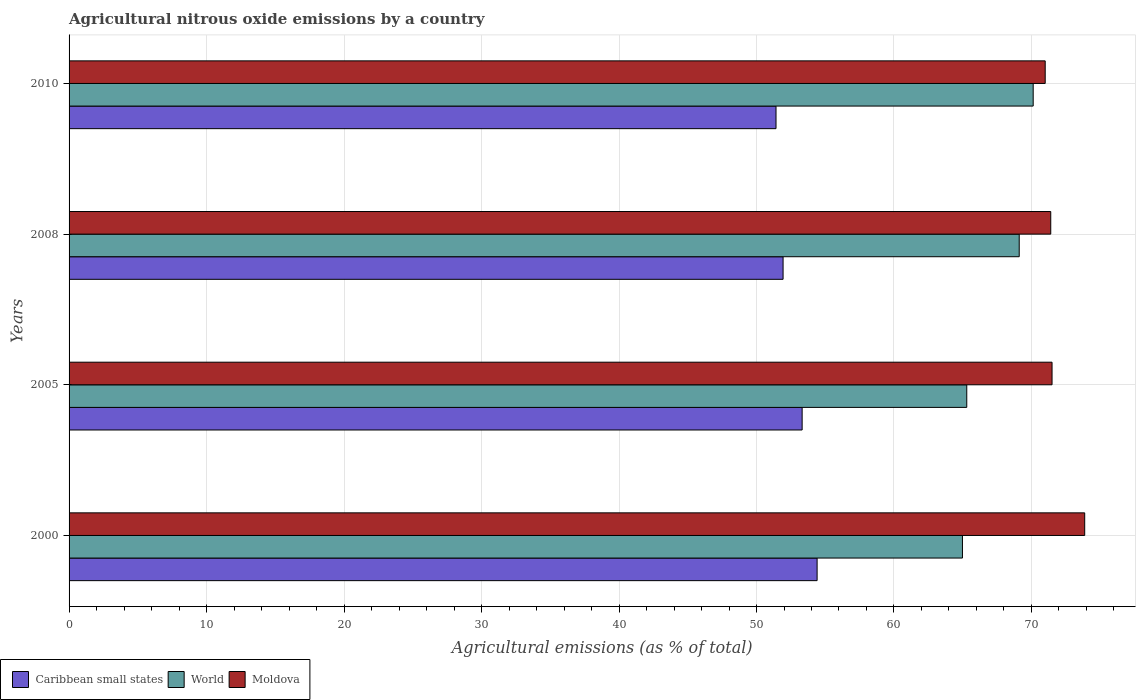How many groups of bars are there?
Your response must be concise. 4. Are the number of bars per tick equal to the number of legend labels?
Ensure brevity in your answer.  Yes. In how many cases, is the number of bars for a given year not equal to the number of legend labels?
Your answer should be very brief. 0. What is the amount of agricultural nitrous oxide emitted in World in 2000?
Make the answer very short. 64.98. Across all years, what is the maximum amount of agricultural nitrous oxide emitted in Moldova?
Offer a terse response. 73.87. Across all years, what is the minimum amount of agricultural nitrous oxide emitted in World?
Your answer should be compact. 64.98. In which year was the amount of agricultural nitrous oxide emitted in Moldova maximum?
Give a very brief answer. 2000. What is the total amount of agricultural nitrous oxide emitted in Caribbean small states in the graph?
Provide a succinct answer. 211.08. What is the difference between the amount of agricultural nitrous oxide emitted in World in 2000 and that in 2005?
Your response must be concise. -0.31. What is the difference between the amount of agricultural nitrous oxide emitted in World in 2005 and the amount of agricultural nitrous oxide emitted in Caribbean small states in 2000?
Your response must be concise. 10.89. What is the average amount of agricultural nitrous oxide emitted in Moldova per year?
Your answer should be very brief. 71.94. In the year 2010, what is the difference between the amount of agricultural nitrous oxide emitted in Caribbean small states and amount of agricultural nitrous oxide emitted in Moldova?
Give a very brief answer. -19.58. In how many years, is the amount of agricultural nitrous oxide emitted in Caribbean small states greater than 48 %?
Your answer should be very brief. 4. What is the ratio of the amount of agricultural nitrous oxide emitted in Caribbean small states in 2000 to that in 2010?
Provide a short and direct response. 1.06. Is the amount of agricultural nitrous oxide emitted in Caribbean small states in 2005 less than that in 2008?
Provide a short and direct response. No. Is the difference between the amount of agricultural nitrous oxide emitted in Caribbean small states in 2005 and 2010 greater than the difference between the amount of agricultural nitrous oxide emitted in Moldova in 2005 and 2010?
Your response must be concise. Yes. What is the difference between the highest and the second highest amount of agricultural nitrous oxide emitted in Moldova?
Make the answer very short. 2.38. What is the difference between the highest and the lowest amount of agricultural nitrous oxide emitted in World?
Give a very brief answer. 5.15. What does the 1st bar from the top in 2000 represents?
Provide a succinct answer. Moldova. What does the 1st bar from the bottom in 2005 represents?
Give a very brief answer. Caribbean small states. Is it the case that in every year, the sum of the amount of agricultural nitrous oxide emitted in Caribbean small states and amount of agricultural nitrous oxide emitted in World is greater than the amount of agricultural nitrous oxide emitted in Moldova?
Your answer should be very brief. Yes. Are all the bars in the graph horizontal?
Your response must be concise. Yes. Does the graph contain grids?
Make the answer very short. Yes. How many legend labels are there?
Your response must be concise. 3. How are the legend labels stacked?
Make the answer very short. Horizontal. What is the title of the graph?
Provide a succinct answer. Agricultural nitrous oxide emissions by a country. Does "Slovenia" appear as one of the legend labels in the graph?
Provide a short and direct response. No. What is the label or title of the X-axis?
Make the answer very short. Agricultural emissions (as % of total). What is the Agricultural emissions (as % of total) of Caribbean small states in 2000?
Offer a terse response. 54.41. What is the Agricultural emissions (as % of total) in World in 2000?
Offer a terse response. 64.98. What is the Agricultural emissions (as % of total) in Moldova in 2000?
Offer a terse response. 73.87. What is the Agricultural emissions (as % of total) of Caribbean small states in 2005?
Your response must be concise. 53.32. What is the Agricultural emissions (as % of total) in World in 2005?
Provide a short and direct response. 65.29. What is the Agricultural emissions (as % of total) in Moldova in 2005?
Offer a very short reply. 71.5. What is the Agricultural emissions (as % of total) in Caribbean small states in 2008?
Provide a succinct answer. 51.93. What is the Agricultural emissions (as % of total) of World in 2008?
Provide a succinct answer. 69.11. What is the Agricultural emissions (as % of total) in Moldova in 2008?
Offer a terse response. 71.4. What is the Agricultural emissions (as % of total) in Caribbean small states in 2010?
Keep it short and to the point. 51.42. What is the Agricultural emissions (as % of total) in World in 2010?
Offer a terse response. 70.13. What is the Agricultural emissions (as % of total) in Moldova in 2010?
Your response must be concise. 71. Across all years, what is the maximum Agricultural emissions (as % of total) in Caribbean small states?
Give a very brief answer. 54.41. Across all years, what is the maximum Agricultural emissions (as % of total) of World?
Offer a very short reply. 70.13. Across all years, what is the maximum Agricultural emissions (as % of total) of Moldova?
Your answer should be very brief. 73.87. Across all years, what is the minimum Agricultural emissions (as % of total) of Caribbean small states?
Your response must be concise. 51.42. Across all years, what is the minimum Agricultural emissions (as % of total) in World?
Keep it short and to the point. 64.98. Across all years, what is the minimum Agricultural emissions (as % of total) in Moldova?
Give a very brief answer. 71. What is the total Agricultural emissions (as % of total) in Caribbean small states in the graph?
Give a very brief answer. 211.08. What is the total Agricultural emissions (as % of total) in World in the graph?
Your answer should be compact. 269.51. What is the total Agricultural emissions (as % of total) of Moldova in the graph?
Offer a very short reply. 287.77. What is the difference between the Agricultural emissions (as % of total) of Caribbean small states in 2000 and that in 2005?
Provide a succinct answer. 1.09. What is the difference between the Agricultural emissions (as % of total) of World in 2000 and that in 2005?
Provide a short and direct response. -0.31. What is the difference between the Agricultural emissions (as % of total) of Moldova in 2000 and that in 2005?
Provide a succinct answer. 2.38. What is the difference between the Agricultural emissions (as % of total) in Caribbean small states in 2000 and that in 2008?
Give a very brief answer. 2.47. What is the difference between the Agricultural emissions (as % of total) in World in 2000 and that in 2008?
Ensure brevity in your answer.  -4.13. What is the difference between the Agricultural emissions (as % of total) of Moldova in 2000 and that in 2008?
Offer a terse response. 2.47. What is the difference between the Agricultural emissions (as % of total) of Caribbean small states in 2000 and that in 2010?
Your answer should be very brief. 2.99. What is the difference between the Agricultural emissions (as % of total) in World in 2000 and that in 2010?
Provide a short and direct response. -5.15. What is the difference between the Agricultural emissions (as % of total) in Moldova in 2000 and that in 2010?
Offer a very short reply. 2.87. What is the difference between the Agricultural emissions (as % of total) in Caribbean small states in 2005 and that in 2008?
Keep it short and to the point. 1.39. What is the difference between the Agricultural emissions (as % of total) in World in 2005 and that in 2008?
Give a very brief answer. -3.82. What is the difference between the Agricultural emissions (as % of total) of Moldova in 2005 and that in 2008?
Offer a terse response. 0.09. What is the difference between the Agricultural emissions (as % of total) of Caribbean small states in 2005 and that in 2010?
Your answer should be very brief. 1.9. What is the difference between the Agricultural emissions (as % of total) of World in 2005 and that in 2010?
Ensure brevity in your answer.  -4.83. What is the difference between the Agricultural emissions (as % of total) of Moldova in 2005 and that in 2010?
Provide a succinct answer. 0.5. What is the difference between the Agricultural emissions (as % of total) of Caribbean small states in 2008 and that in 2010?
Give a very brief answer. 0.51. What is the difference between the Agricultural emissions (as % of total) of World in 2008 and that in 2010?
Ensure brevity in your answer.  -1.02. What is the difference between the Agricultural emissions (as % of total) of Moldova in 2008 and that in 2010?
Your answer should be very brief. 0.4. What is the difference between the Agricultural emissions (as % of total) of Caribbean small states in 2000 and the Agricultural emissions (as % of total) of World in 2005?
Ensure brevity in your answer.  -10.89. What is the difference between the Agricultural emissions (as % of total) in Caribbean small states in 2000 and the Agricultural emissions (as % of total) in Moldova in 2005?
Provide a succinct answer. -17.09. What is the difference between the Agricultural emissions (as % of total) in World in 2000 and the Agricultural emissions (as % of total) in Moldova in 2005?
Provide a succinct answer. -6.52. What is the difference between the Agricultural emissions (as % of total) in Caribbean small states in 2000 and the Agricultural emissions (as % of total) in World in 2008?
Ensure brevity in your answer.  -14.7. What is the difference between the Agricultural emissions (as % of total) of Caribbean small states in 2000 and the Agricultural emissions (as % of total) of Moldova in 2008?
Your answer should be compact. -16.99. What is the difference between the Agricultural emissions (as % of total) of World in 2000 and the Agricultural emissions (as % of total) of Moldova in 2008?
Your response must be concise. -6.42. What is the difference between the Agricultural emissions (as % of total) in Caribbean small states in 2000 and the Agricultural emissions (as % of total) in World in 2010?
Offer a very short reply. -15.72. What is the difference between the Agricultural emissions (as % of total) in Caribbean small states in 2000 and the Agricultural emissions (as % of total) in Moldova in 2010?
Provide a succinct answer. -16.59. What is the difference between the Agricultural emissions (as % of total) in World in 2000 and the Agricultural emissions (as % of total) in Moldova in 2010?
Give a very brief answer. -6.02. What is the difference between the Agricultural emissions (as % of total) of Caribbean small states in 2005 and the Agricultural emissions (as % of total) of World in 2008?
Offer a terse response. -15.79. What is the difference between the Agricultural emissions (as % of total) of Caribbean small states in 2005 and the Agricultural emissions (as % of total) of Moldova in 2008?
Give a very brief answer. -18.08. What is the difference between the Agricultural emissions (as % of total) of World in 2005 and the Agricultural emissions (as % of total) of Moldova in 2008?
Provide a short and direct response. -6.11. What is the difference between the Agricultural emissions (as % of total) in Caribbean small states in 2005 and the Agricultural emissions (as % of total) in World in 2010?
Keep it short and to the point. -16.81. What is the difference between the Agricultural emissions (as % of total) in Caribbean small states in 2005 and the Agricultural emissions (as % of total) in Moldova in 2010?
Your answer should be compact. -17.68. What is the difference between the Agricultural emissions (as % of total) of World in 2005 and the Agricultural emissions (as % of total) of Moldova in 2010?
Provide a short and direct response. -5.7. What is the difference between the Agricultural emissions (as % of total) of Caribbean small states in 2008 and the Agricultural emissions (as % of total) of World in 2010?
Offer a terse response. -18.19. What is the difference between the Agricultural emissions (as % of total) in Caribbean small states in 2008 and the Agricultural emissions (as % of total) in Moldova in 2010?
Offer a very short reply. -19.07. What is the difference between the Agricultural emissions (as % of total) of World in 2008 and the Agricultural emissions (as % of total) of Moldova in 2010?
Your answer should be compact. -1.89. What is the average Agricultural emissions (as % of total) in Caribbean small states per year?
Provide a short and direct response. 52.77. What is the average Agricultural emissions (as % of total) in World per year?
Make the answer very short. 67.38. What is the average Agricultural emissions (as % of total) of Moldova per year?
Your response must be concise. 71.94. In the year 2000, what is the difference between the Agricultural emissions (as % of total) of Caribbean small states and Agricultural emissions (as % of total) of World?
Your answer should be compact. -10.57. In the year 2000, what is the difference between the Agricultural emissions (as % of total) in Caribbean small states and Agricultural emissions (as % of total) in Moldova?
Your answer should be very brief. -19.46. In the year 2000, what is the difference between the Agricultural emissions (as % of total) of World and Agricultural emissions (as % of total) of Moldova?
Keep it short and to the point. -8.89. In the year 2005, what is the difference between the Agricultural emissions (as % of total) in Caribbean small states and Agricultural emissions (as % of total) in World?
Make the answer very short. -11.97. In the year 2005, what is the difference between the Agricultural emissions (as % of total) of Caribbean small states and Agricultural emissions (as % of total) of Moldova?
Keep it short and to the point. -18.18. In the year 2005, what is the difference between the Agricultural emissions (as % of total) of World and Agricultural emissions (as % of total) of Moldova?
Ensure brevity in your answer.  -6.2. In the year 2008, what is the difference between the Agricultural emissions (as % of total) of Caribbean small states and Agricultural emissions (as % of total) of World?
Offer a terse response. -17.18. In the year 2008, what is the difference between the Agricultural emissions (as % of total) in Caribbean small states and Agricultural emissions (as % of total) in Moldova?
Make the answer very short. -19.47. In the year 2008, what is the difference between the Agricultural emissions (as % of total) in World and Agricultural emissions (as % of total) in Moldova?
Your answer should be compact. -2.29. In the year 2010, what is the difference between the Agricultural emissions (as % of total) in Caribbean small states and Agricultural emissions (as % of total) in World?
Give a very brief answer. -18.71. In the year 2010, what is the difference between the Agricultural emissions (as % of total) of Caribbean small states and Agricultural emissions (as % of total) of Moldova?
Keep it short and to the point. -19.58. In the year 2010, what is the difference between the Agricultural emissions (as % of total) of World and Agricultural emissions (as % of total) of Moldova?
Ensure brevity in your answer.  -0.87. What is the ratio of the Agricultural emissions (as % of total) in Caribbean small states in 2000 to that in 2005?
Keep it short and to the point. 1.02. What is the ratio of the Agricultural emissions (as % of total) in World in 2000 to that in 2005?
Provide a short and direct response. 1. What is the ratio of the Agricultural emissions (as % of total) of Moldova in 2000 to that in 2005?
Your answer should be very brief. 1.03. What is the ratio of the Agricultural emissions (as % of total) in Caribbean small states in 2000 to that in 2008?
Your answer should be compact. 1.05. What is the ratio of the Agricultural emissions (as % of total) of World in 2000 to that in 2008?
Your answer should be very brief. 0.94. What is the ratio of the Agricultural emissions (as % of total) in Moldova in 2000 to that in 2008?
Provide a succinct answer. 1.03. What is the ratio of the Agricultural emissions (as % of total) of Caribbean small states in 2000 to that in 2010?
Keep it short and to the point. 1.06. What is the ratio of the Agricultural emissions (as % of total) in World in 2000 to that in 2010?
Offer a terse response. 0.93. What is the ratio of the Agricultural emissions (as % of total) in Moldova in 2000 to that in 2010?
Your response must be concise. 1.04. What is the ratio of the Agricultural emissions (as % of total) in Caribbean small states in 2005 to that in 2008?
Provide a short and direct response. 1.03. What is the ratio of the Agricultural emissions (as % of total) in World in 2005 to that in 2008?
Your answer should be compact. 0.94. What is the ratio of the Agricultural emissions (as % of total) of Moldova in 2005 to that in 2008?
Provide a succinct answer. 1. What is the ratio of the Agricultural emissions (as % of total) in Caribbean small states in 2005 to that in 2010?
Provide a succinct answer. 1.04. What is the ratio of the Agricultural emissions (as % of total) of World in 2005 to that in 2010?
Keep it short and to the point. 0.93. What is the ratio of the Agricultural emissions (as % of total) of Moldova in 2005 to that in 2010?
Ensure brevity in your answer.  1.01. What is the ratio of the Agricultural emissions (as % of total) of World in 2008 to that in 2010?
Provide a short and direct response. 0.99. What is the difference between the highest and the second highest Agricultural emissions (as % of total) in Caribbean small states?
Give a very brief answer. 1.09. What is the difference between the highest and the second highest Agricultural emissions (as % of total) of World?
Offer a terse response. 1.02. What is the difference between the highest and the second highest Agricultural emissions (as % of total) of Moldova?
Give a very brief answer. 2.38. What is the difference between the highest and the lowest Agricultural emissions (as % of total) of Caribbean small states?
Your answer should be very brief. 2.99. What is the difference between the highest and the lowest Agricultural emissions (as % of total) in World?
Make the answer very short. 5.15. What is the difference between the highest and the lowest Agricultural emissions (as % of total) in Moldova?
Give a very brief answer. 2.87. 